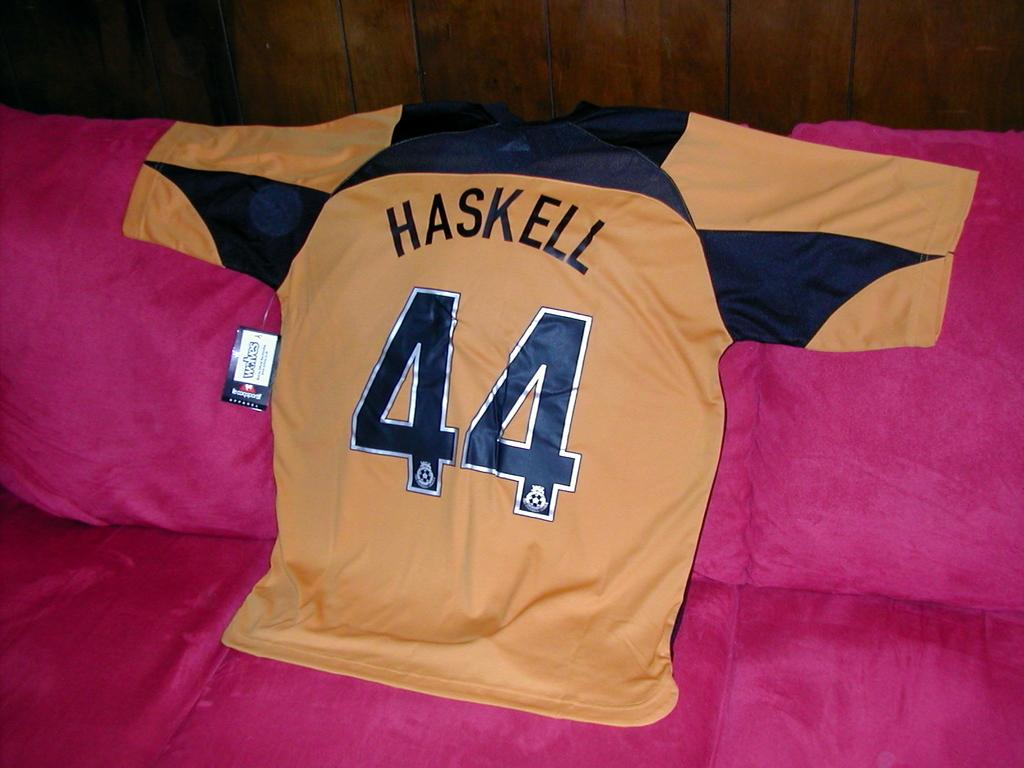<image>
Give a short and clear explanation of the subsequent image. The young man brought his favorite "Haskell" jersey for the hockey game. 